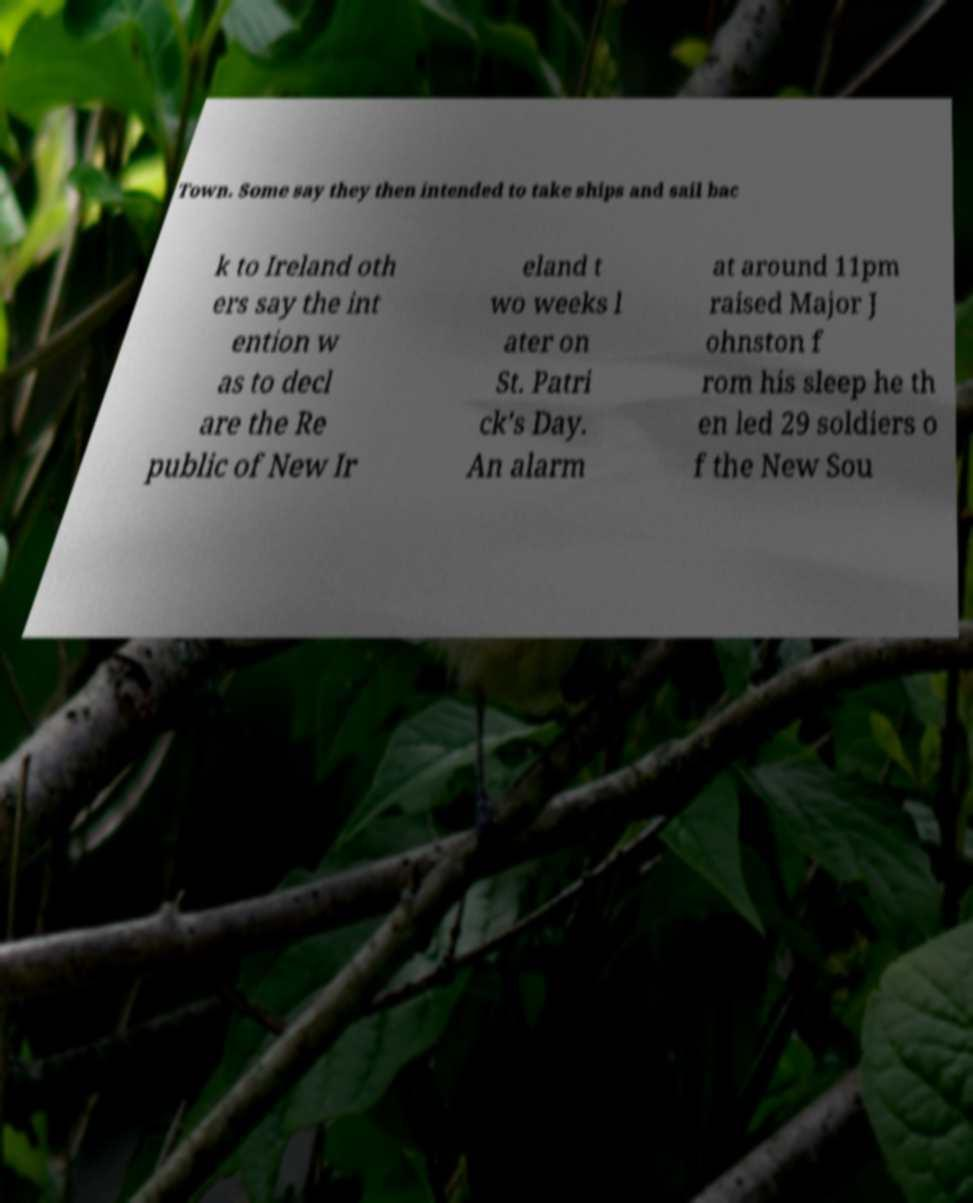I need the written content from this picture converted into text. Can you do that? Town. Some say they then intended to take ships and sail bac k to Ireland oth ers say the int ention w as to decl are the Re public of New Ir eland t wo weeks l ater on St. Patri ck's Day. An alarm at around 11pm raised Major J ohnston f rom his sleep he th en led 29 soldiers o f the New Sou 